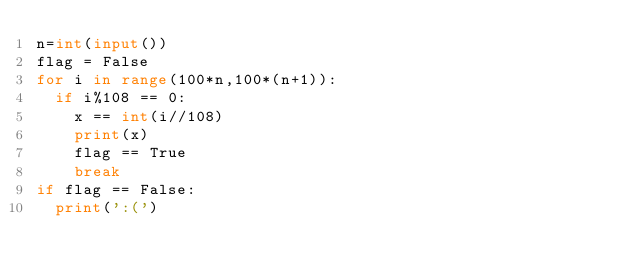<code> <loc_0><loc_0><loc_500><loc_500><_Python_>n=int(input()) 
flag = False
for i in range(100*n,100*(n+1)):
  if i%108 == 0:
    x == int(i//108)
    print(x)
    flag == True
    break
if flag == False:
  print(':(')</code> 